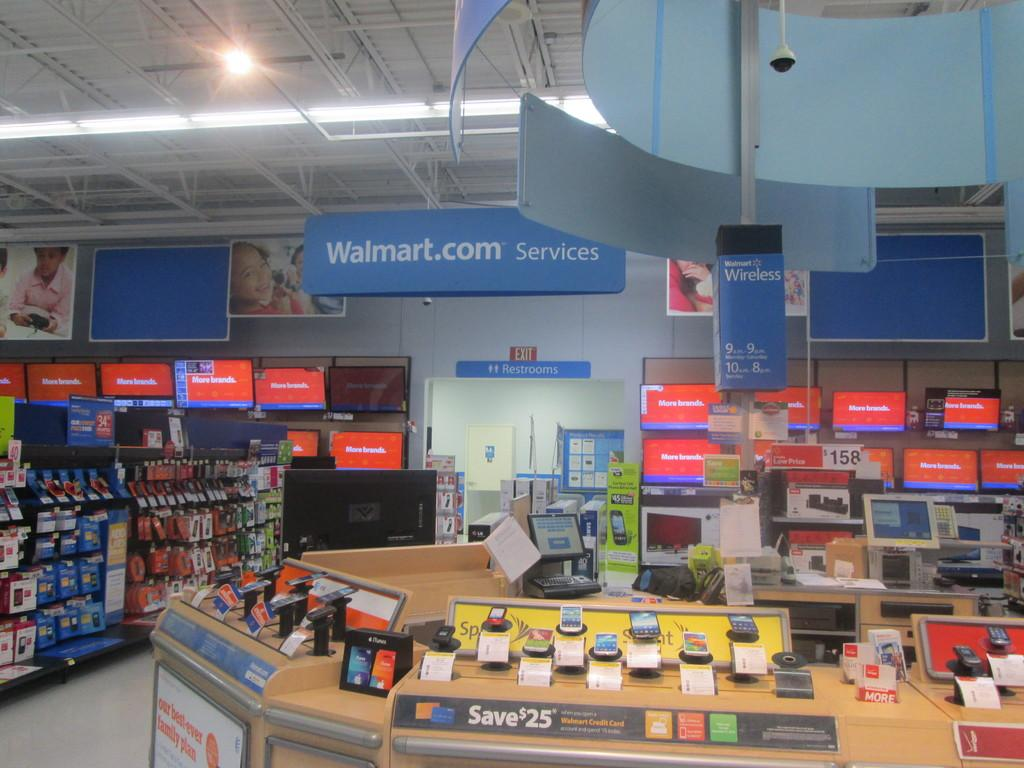<image>
Describe the image concisely. One can save $25 on selected phones at this Walmart. 